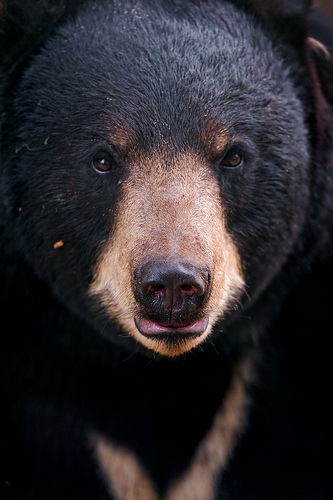Please provide a short description for this region: [0.42, 0.61, 0.6, 0.7]. The region indicated by the coordinates [0.42, 0.61, 0.6, 0.7] shows a bear's mouth. The mouth's placement and the visible tongue suggest the bear might be in the act of making a sound or showing its tongue. 